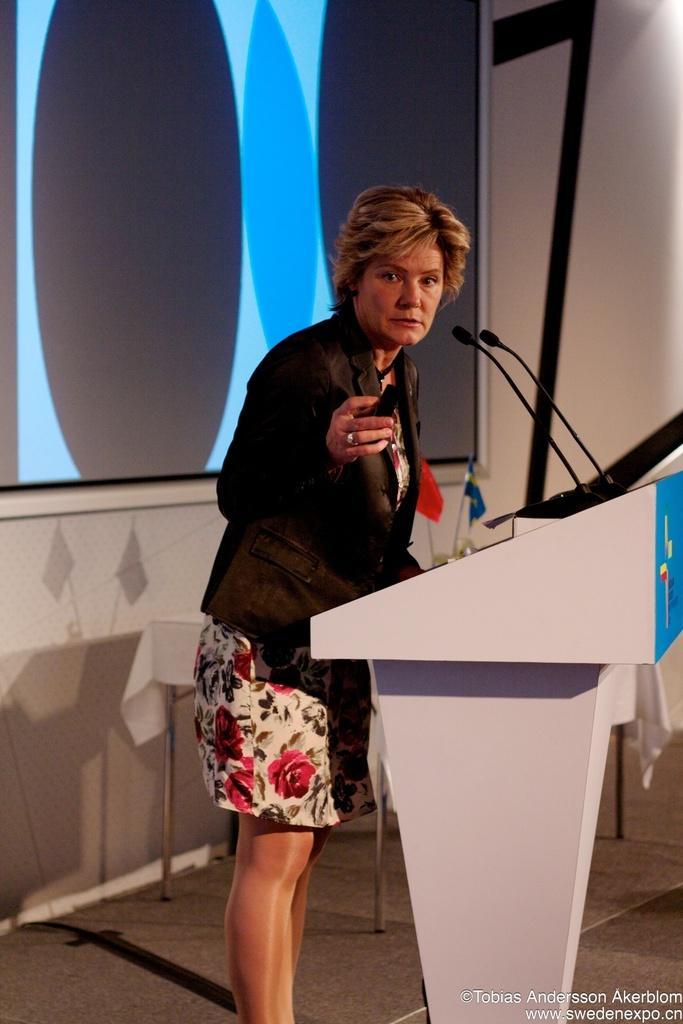Could you give a brief overview of what you see in this image? In this image there is a person standing in front of the podium. On top of the podium there are mike's. Behind the person there is a table. On top of it there are flags. In the background of the image there is a screen on the wall. There is some text at the bottom of the image. 